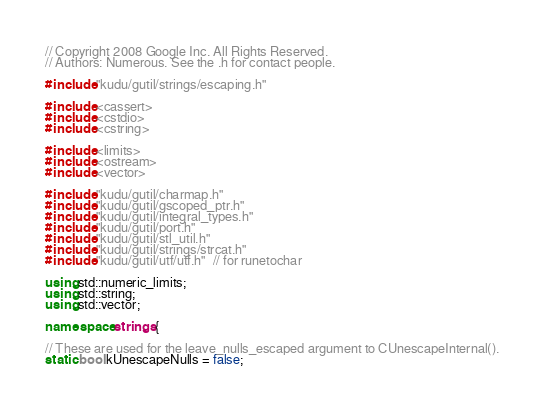<code> <loc_0><loc_0><loc_500><loc_500><_C++_>// Copyright 2008 Google Inc. All Rights Reserved.
// Authors: Numerous. See the .h for contact people.

#include "kudu/gutil/strings/escaping.h"

#include <cassert>
#include <cstdio>
#include <cstring>

#include <limits>
#include <ostream>
#include <vector>

#include "kudu/gutil/charmap.h"
#include "kudu/gutil/gscoped_ptr.h"
#include "kudu/gutil/integral_types.h"
#include "kudu/gutil/port.h"
#include "kudu/gutil/stl_util.h"
#include "kudu/gutil/strings/strcat.h"
#include "kudu/gutil/utf/utf.h"  // for runetochar

using std::numeric_limits;
using std::string;
using std::vector;

namespace strings {

// These are used for the leave_nulls_escaped argument to CUnescapeInternal().
static bool kUnescapeNulls = false;</code> 